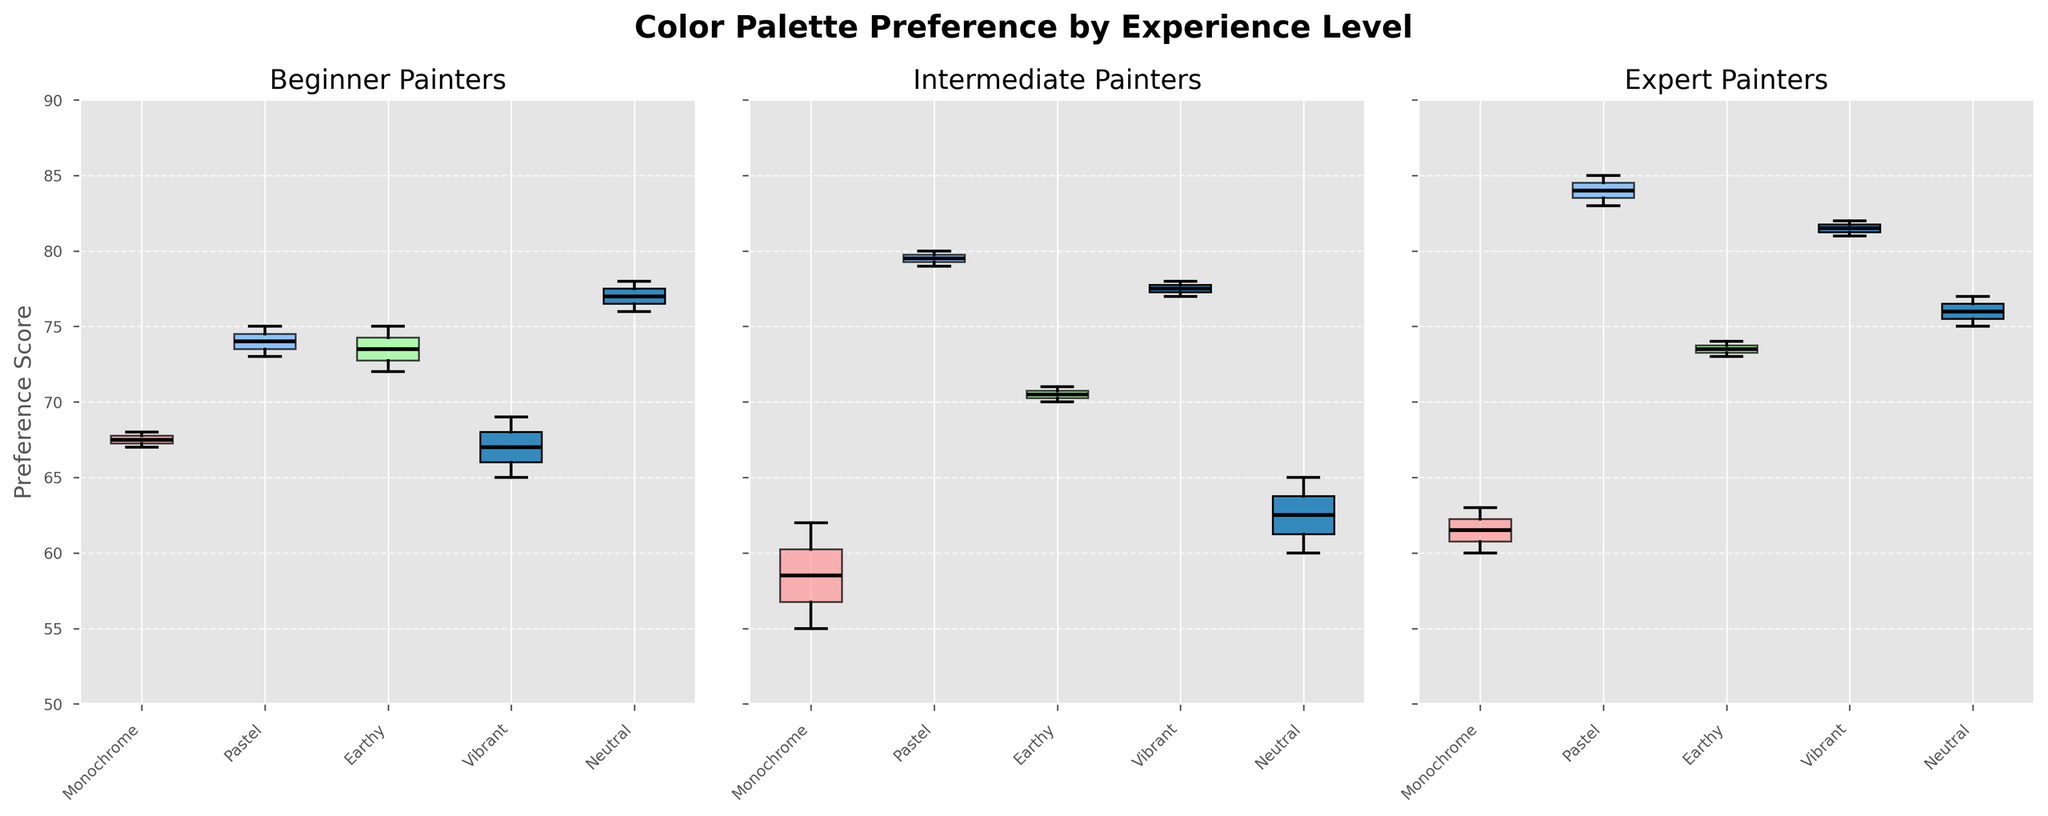How many experience levels are shown in the figure? The titles of the subplots are "Beginner Painters", "Intermediate Painters", and "Expert Painters", which indicates three different experience levels.
Answer: Three What does the y-axis represent in the figure? The y-axis has a label "Preference Score", showing the preference scores for different color palettes.
Answer: Preference Score Which color palette has the highest median preference score among Beginner painters? For Beginner painters, the box plot with the highest median line (black line in the box) corresponds to the "Neutral" color palette.
Answer: Neutral What is the range of the y-axis in all subplots? All subplots have y-axes ranging from 50 to 90 as shown by the consistent limits across the subplots.
Answer: 50 to 90 Which experience level shows the greatest variability in preference scores for the Monochrome palette? The box plot for Monochrome shows greater whisker length and potential outliers for the Beginner level compared to Intermediate and Expert levels, indicating greater variability.
Answer: Beginner Which experience level has the most consistent preference score for the Pastel palette, based on the box plot? The box plot for the Expert painters has the smallest interquartile range (IQR) for the Pastel palette, indicating the most consistent preference scores.
Answer: Expert What can be inferred about the relative preference for the Vibrant palette between Intermediate and Expert painters? The median line in the box plot for the Vibrant palette is slightly higher in the Expert level subplot when compared to the Intermediate level, suggesting that Expert painters have a slightly higher preference for Vibrant palettes.
Answer: Experts prefer Vibrant palettes more Is the median preference score for the Earthy palette higher for Intermediate painters or Beginner painters? By comparing the median lines in the Earthy palette box plots, Intermediate painters have a lower median preference score than Beginner painters.
Answer: Beginner painters Which color palette seems to be least preferred by Intermediate painters? Among Intermediate painters, the Monochrome palette has the lowest median score, indicating it is the least preferred.
Answer: Monochrome What insight does the figure provide about the preference scores of Neutral palettes across all experience levels? Neutral palettes appear to have relatively high median preference scores across all experience levels, with scores consistently higher than other palettes.
Answer: Consistently high preference scores 